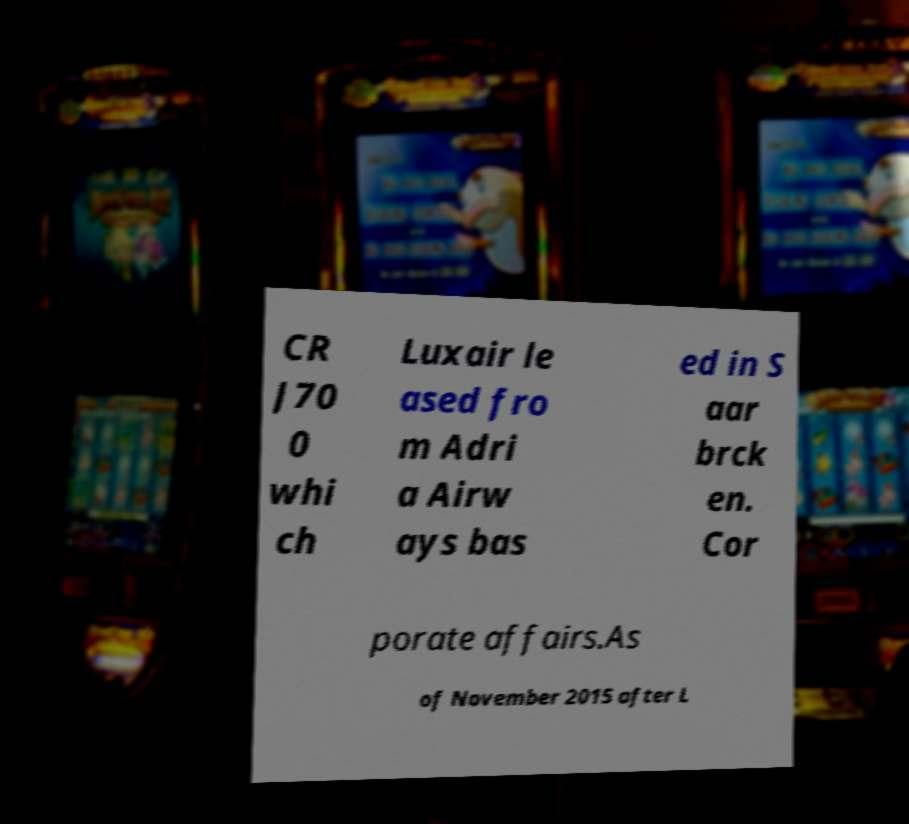For documentation purposes, I need the text within this image transcribed. Could you provide that? CR J70 0 whi ch Luxair le ased fro m Adri a Airw ays bas ed in S aar brck en. Cor porate affairs.As of November 2015 after L 